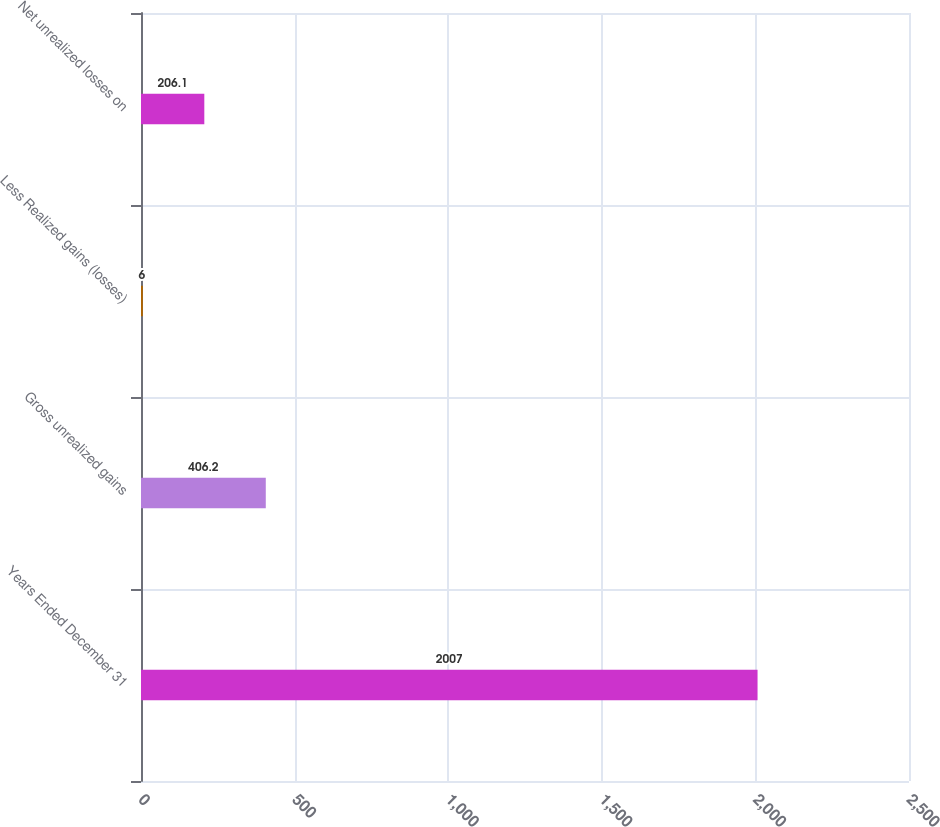<chart> <loc_0><loc_0><loc_500><loc_500><bar_chart><fcel>Years Ended December 31<fcel>Gross unrealized gains<fcel>Less Realized gains (losses)<fcel>Net unrealized losses on<nl><fcel>2007<fcel>406.2<fcel>6<fcel>206.1<nl></chart> 